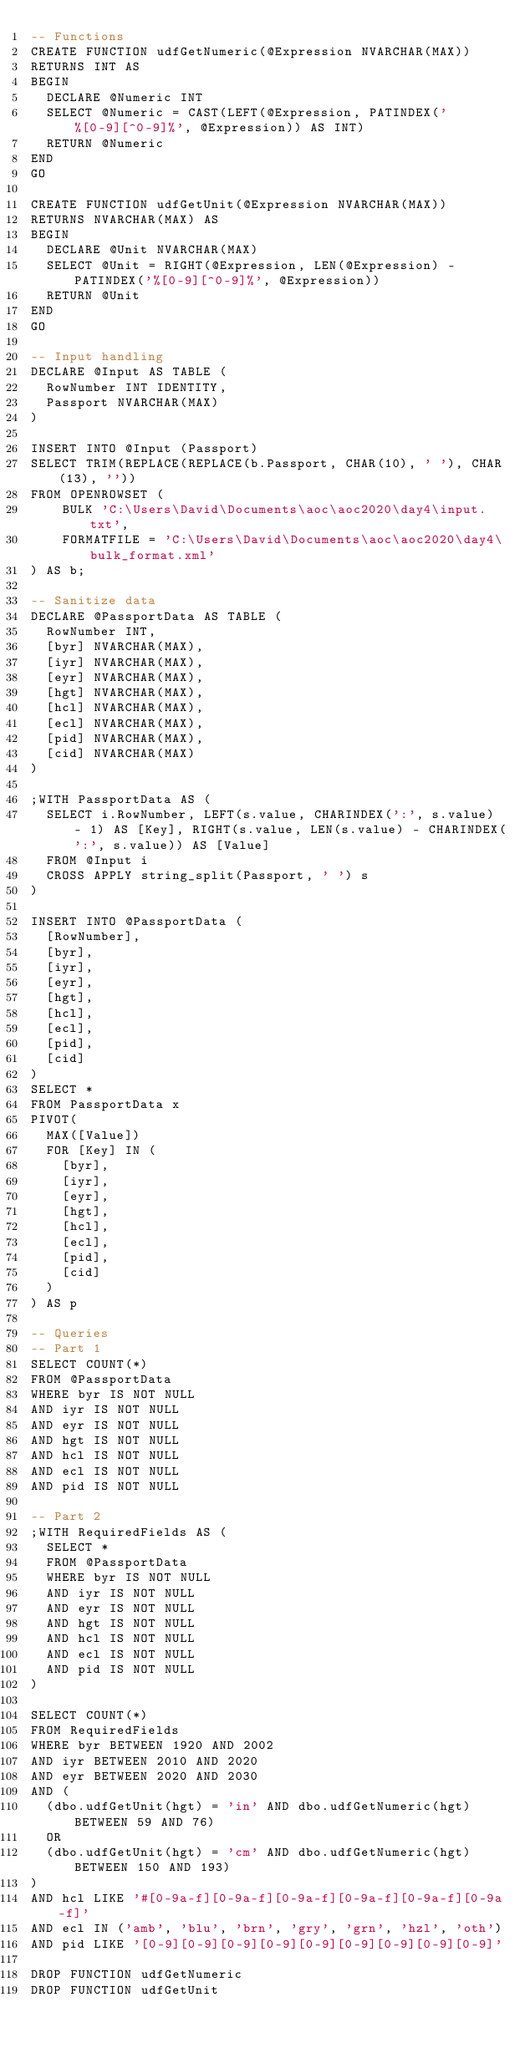Convert code to text. <code><loc_0><loc_0><loc_500><loc_500><_SQL_>-- Functions
CREATE FUNCTION udfGetNumeric(@Expression NVARCHAR(MAX))
RETURNS INT AS 
BEGIN 
	DECLARE @Numeric INT
	SELECT @Numeric = CAST(LEFT(@Expression, PATINDEX('%[0-9][^0-9]%', @Expression)) AS INT)
	RETURN @Numeric
END
GO

CREATE FUNCTION udfGetUnit(@Expression NVARCHAR(MAX))
RETURNS NVARCHAR(MAX) AS 
BEGIN 
	DECLARE @Unit NVARCHAR(MAX)
	SELECT @Unit = RIGHT(@Expression, LEN(@Expression) - PATINDEX('%[0-9][^0-9]%', @Expression))
	RETURN @Unit
END
GO

-- Input handling
DECLARE @Input AS TABLE (
	RowNumber INT IDENTITY,
	Passport NVARCHAR(MAX)
)

INSERT INTO @Input (Passport)
SELECT TRIM(REPLACE(REPLACE(b.Passport, CHAR(10), ' '), CHAR(13), ''))
FROM OPENROWSET (
		BULK 'C:\Users\David\Documents\aoc\aoc2020\day4\input.txt',
		FORMATFILE = 'C:\Users\David\Documents\aoc\aoc2020\day4\bulk_format.xml'  
) AS b;

-- Sanitize data
DECLARE @PassportData AS TABLE (
	RowNumber INT,
	[byr] NVARCHAR(MAX),
	[iyr] NVARCHAR(MAX),
	[eyr] NVARCHAR(MAX),
	[hgt] NVARCHAR(MAX),
	[hcl] NVARCHAR(MAX),
	[ecl] NVARCHAR(MAX),
	[pid] NVARCHAR(MAX),
	[cid] NVARCHAR(MAX)
)

;WITH PassportData AS (
	SELECT i.RowNumber, LEFT(s.value, CHARINDEX(':', s.value) - 1) AS [Key], RIGHT(s.value, LEN(s.value) - CHARINDEX(':', s.value)) AS [Value]
	FROM @Input i
	CROSS APPLY string_split(Passport, ' ') s
)

INSERT INTO @PassportData (
	[RowNumber], 
	[byr],
	[iyr],
	[eyr],
	[hgt],
	[hcl],
	[ecl],
	[pid],
	[cid]
)
SELECT *
FROM PassportData x
PIVOT(
	MAX([Value])
	FOR [Key] IN (
		[byr],
		[iyr],
		[eyr],
		[hgt],
		[hcl],
		[ecl],
		[pid],
		[cid]
	)
) AS p

-- Queries
-- Part 1
SELECT COUNT(*)
FROM @PassportData
WHERE byr IS NOT NULL
AND iyr IS NOT NULL
AND eyr IS NOT NULL
AND hgt IS NOT NULL
AND hcl IS NOT NULL
AND ecl IS NOT NULL
AND pid IS NOT NULL

-- Part 2
;WITH RequiredFields AS (
	SELECT *
	FROM @PassportData
	WHERE byr IS NOT NULL
	AND iyr IS NOT NULL
	AND eyr IS NOT NULL
	AND hgt IS NOT NULL
	AND hcl IS NOT NULL
	AND ecl IS NOT NULL
	AND pid IS NOT NULL
)
	
SELECT COUNT(*)
FROM RequiredFields
WHERE byr BETWEEN 1920 AND 2002
AND iyr BETWEEN 2010 AND 2020
AND eyr BETWEEN 2020 AND 2030
AND (
	(dbo.udfGetUnit(hgt) = 'in' AND dbo.udfGetNumeric(hgt) BETWEEN 59 AND 76) 
	OR
	(dbo.udfGetUnit(hgt) = 'cm' AND dbo.udfGetNumeric(hgt) BETWEEN 150 AND 193) 
)
AND hcl LIKE '#[0-9a-f][0-9a-f][0-9a-f][0-9a-f][0-9a-f][0-9a-f]'
AND ecl IN ('amb', 'blu', 'brn', 'gry', 'grn', 'hzl', 'oth')
AND pid LIKE '[0-9][0-9][0-9][0-9][0-9][0-9][0-9][0-9][0-9]'

DROP FUNCTION udfGetNumeric
DROP FUNCTION udfGetUnit</code> 